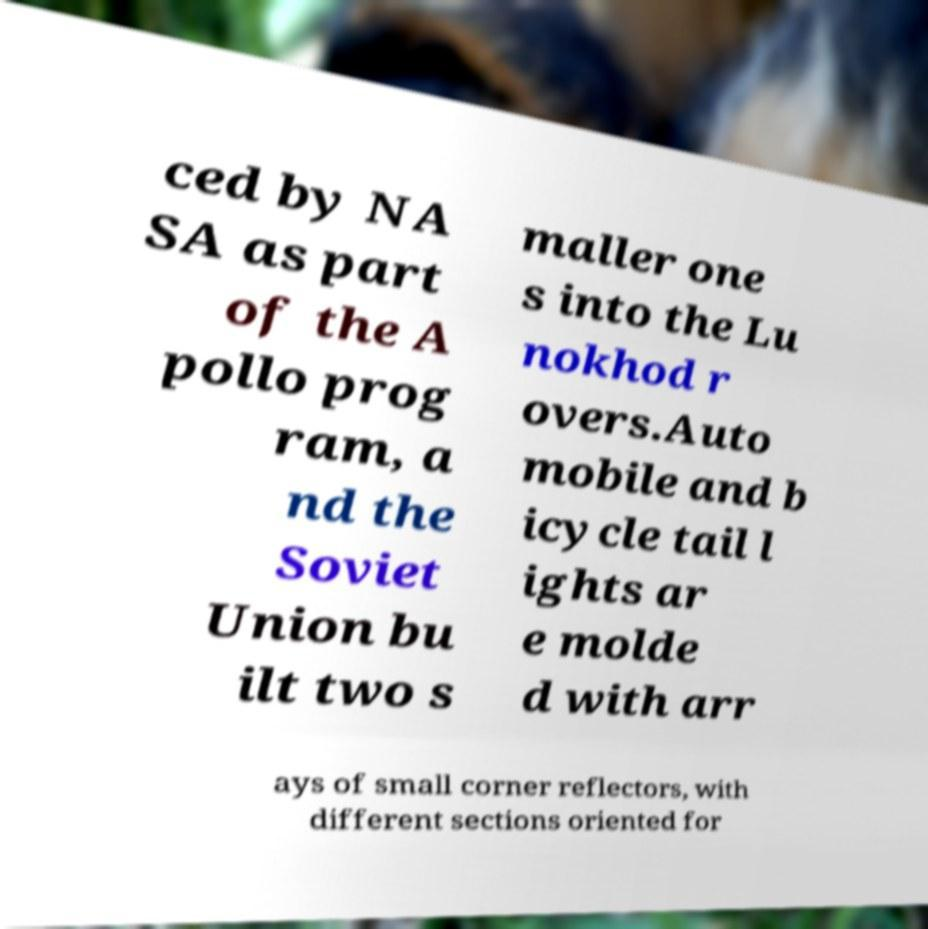Could you assist in decoding the text presented in this image and type it out clearly? ced by NA SA as part of the A pollo prog ram, a nd the Soviet Union bu ilt two s maller one s into the Lu nokhod r overs.Auto mobile and b icycle tail l ights ar e molde d with arr ays of small corner reflectors, with different sections oriented for 